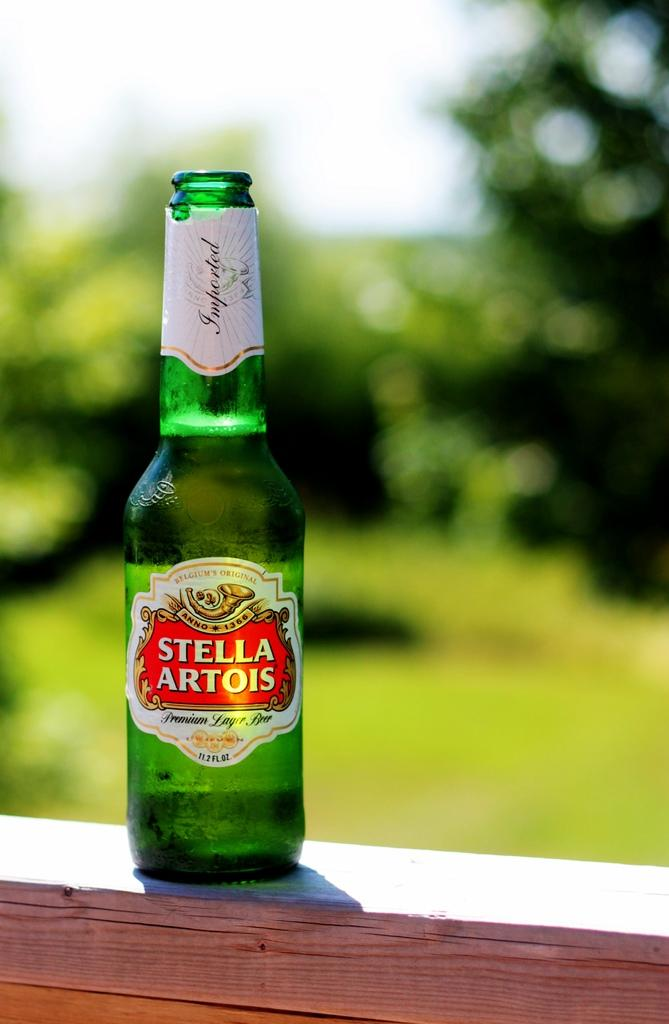<image>
Offer a succinct explanation of the picture presented. a stella artois bottle that is on a wood surface 